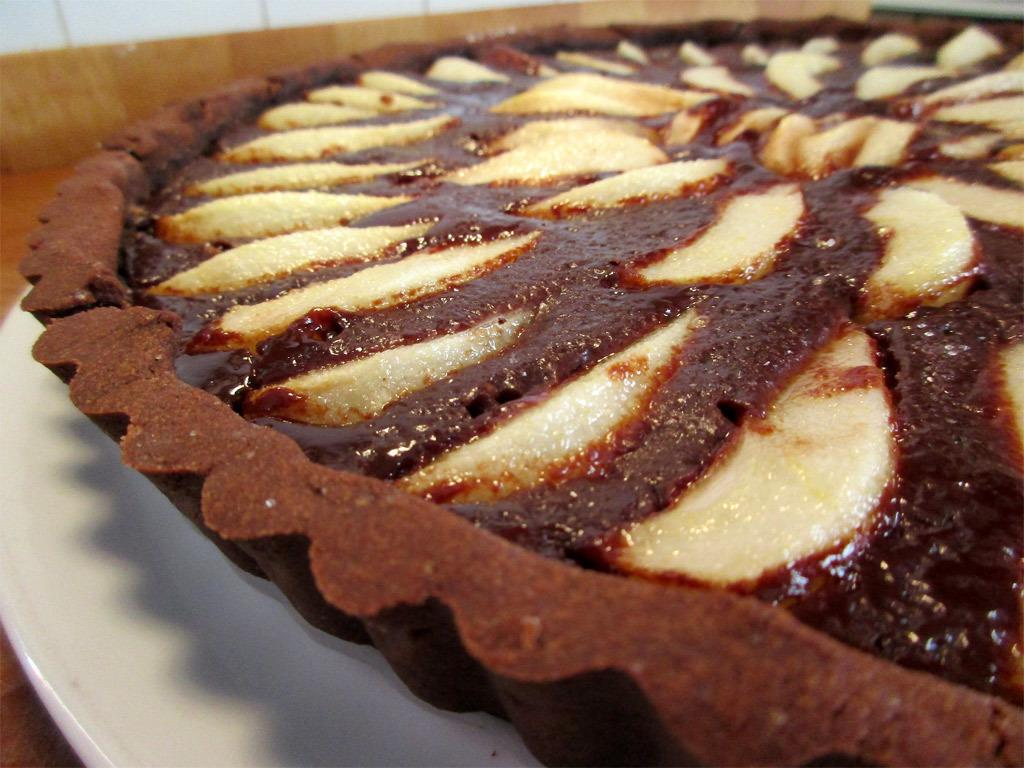What is the main subject of the image? The main subject of the image is a cake. How is the cake presented in the image? The cake is on a plate in the image. What can be observed about the cake's design? The cake has different types of cream layers. How does the cake help clean someone's throat in the image? The cake does not have any function related to cleaning someone's throat in the image. 